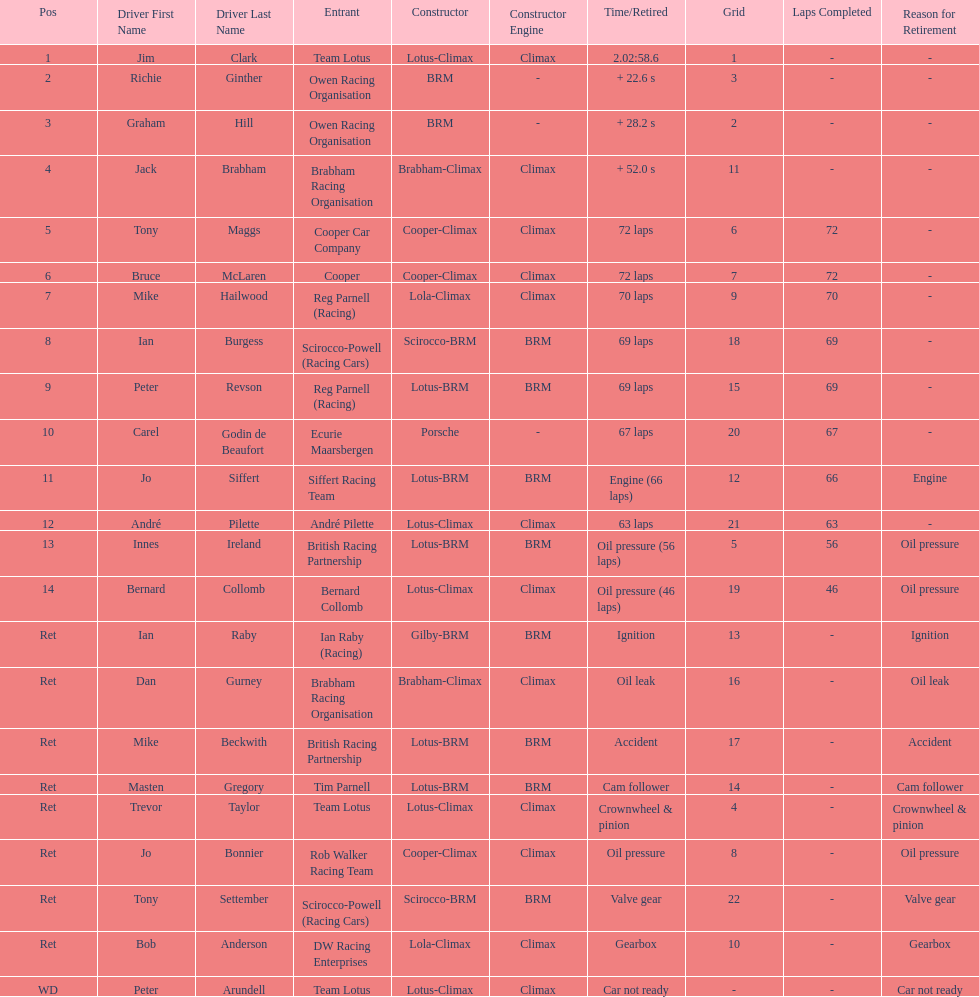Who came in earlier, tony maggs or jo siffert? Tony Maggs. 